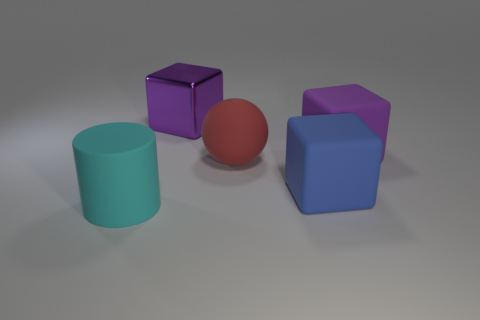There is another object that is the same color as the shiny thing; what is its size?
Ensure brevity in your answer.  Large. What number of objects are to the right of the cyan object?
Make the answer very short. 4. Does the purple thing right of the big blue matte cube have the same shape as the red matte thing?
Ensure brevity in your answer.  No. There is a large matte object that is behind the ball; what is its color?
Make the answer very short. Purple. What shape is the large blue object that is the same material as the red ball?
Offer a very short reply. Cube. Is there any other thing that has the same color as the cylinder?
Provide a succinct answer. No. Is the number of big purple blocks that are to the right of the large red thing greater than the number of large red matte spheres behind the purple matte thing?
Your response must be concise. Yes. What number of gray objects are the same size as the rubber cylinder?
Ensure brevity in your answer.  0. Is the number of cyan matte cylinders that are to the right of the large blue thing less than the number of big purple blocks on the left side of the big red matte sphere?
Your answer should be very brief. Yes. Is there a large gray metallic object that has the same shape as the blue thing?
Your answer should be compact. No. 